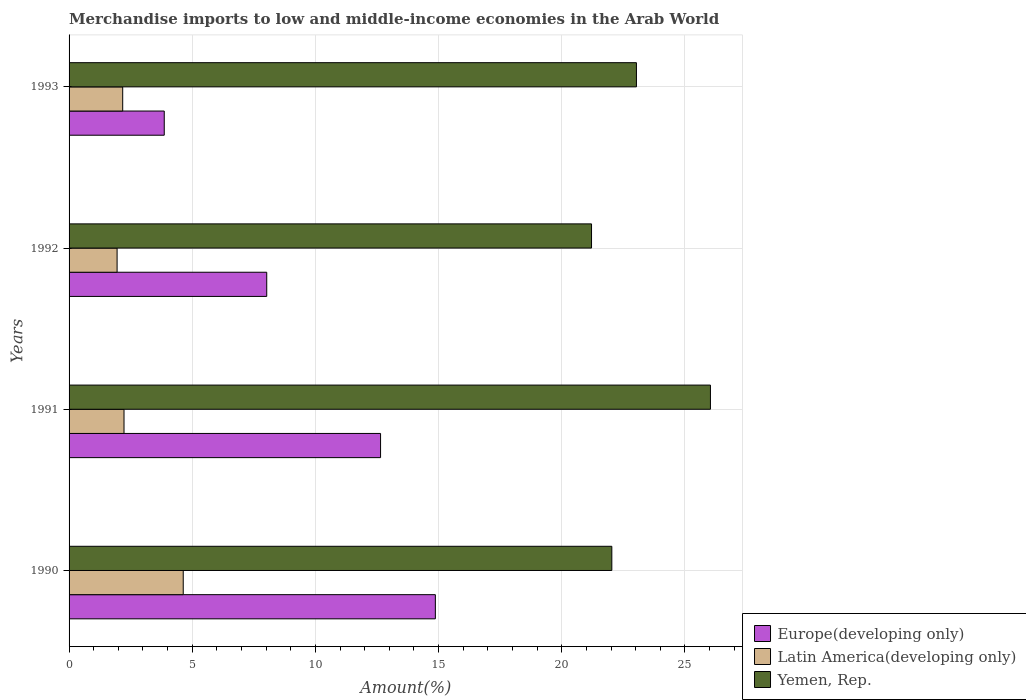How many groups of bars are there?
Offer a terse response. 4. How many bars are there on the 4th tick from the top?
Provide a short and direct response. 3. What is the percentage of amount earned from merchandise imports in Europe(developing only) in 1993?
Your answer should be compact. 3.86. Across all years, what is the maximum percentage of amount earned from merchandise imports in Yemen, Rep.?
Provide a succinct answer. 26.04. Across all years, what is the minimum percentage of amount earned from merchandise imports in Yemen, Rep.?
Keep it short and to the point. 21.21. In which year was the percentage of amount earned from merchandise imports in Yemen, Rep. maximum?
Ensure brevity in your answer.  1991. What is the total percentage of amount earned from merchandise imports in Yemen, Rep. in the graph?
Provide a short and direct response. 92.31. What is the difference between the percentage of amount earned from merchandise imports in Latin America(developing only) in 1991 and that in 1993?
Keep it short and to the point. 0.05. What is the difference between the percentage of amount earned from merchandise imports in Latin America(developing only) in 1992 and the percentage of amount earned from merchandise imports in Europe(developing only) in 1991?
Provide a succinct answer. -10.7. What is the average percentage of amount earned from merchandise imports in Europe(developing only) per year?
Make the answer very short. 9.85. In the year 1993, what is the difference between the percentage of amount earned from merchandise imports in Europe(developing only) and percentage of amount earned from merchandise imports in Latin America(developing only)?
Provide a short and direct response. 1.69. In how many years, is the percentage of amount earned from merchandise imports in Yemen, Rep. greater than 16 %?
Keep it short and to the point. 4. What is the ratio of the percentage of amount earned from merchandise imports in Europe(developing only) in 1991 to that in 1993?
Ensure brevity in your answer.  3.27. Is the percentage of amount earned from merchandise imports in Europe(developing only) in 1990 less than that in 1993?
Offer a very short reply. No. Is the difference between the percentage of amount earned from merchandise imports in Europe(developing only) in 1991 and 1992 greater than the difference between the percentage of amount earned from merchandise imports in Latin America(developing only) in 1991 and 1992?
Offer a terse response. Yes. What is the difference between the highest and the second highest percentage of amount earned from merchandise imports in Latin America(developing only)?
Provide a short and direct response. 2.4. What is the difference between the highest and the lowest percentage of amount earned from merchandise imports in Latin America(developing only)?
Ensure brevity in your answer.  2.68. In how many years, is the percentage of amount earned from merchandise imports in Europe(developing only) greater than the average percentage of amount earned from merchandise imports in Europe(developing only) taken over all years?
Your answer should be very brief. 2. Is the sum of the percentage of amount earned from merchandise imports in Latin America(developing only) in 1990 and 1991 greater than the maximum percentage of amount earned from merchandise imports in Yemen, Rep. across all years?
Give a very brief answer. No. What does the 1st bar from the top in 1992 represents?
Ensure brevity in your answer.  Yemen, Rep. What does the 1st bar from the bottom in 1991 represents?
Offer a terse response. Europe(developing only). How many bars are there?
Make the answer very short. 12. How many years are there in the graph?
Make the answer very short. 4. Are the values on the major ticks of X-axis written in scientific E-notation?
Your answer should be compact. No. Does the graph contain grids?
Offer a terse response. Yes. How many legend labels are there?
Offer a very short reply. 3. What is the title of the graph?
Your response must be concise. Merchandise imports to low and middle-income economies in the Arab World. Does "Singapore" appear as one of the legend labels in the graph?
Give a very brief answer. No. What is the label or title of the X-axis?
Give a very brief answer. Amount(%). What is the label or title of the Y-axis?
Your answer should be very brief. Years. What is the Amount(%) of Europe(developing only) in 1990?
Keep it short and to the point. 14.87. What is the Amount(%) in Latin America(developing only) in 1990?
Keep it short and to the point. 4.63. What is the Amount(%) in Yemen, Rep. in 1990?
Your answer should be compact. 22.03. What is the Amount(%) of Europe(developing only) in 1991?
Give a very brief answer. 12.64. What is the Amount(%) in Latin America(developing only) in 1991?
Provide a succinct answer. 2.23. What is the Amount(%) of Yemen, Rep. in 1991?
Ensure brevity in your answer.  26.04. What is the Amount(%) in Europe(developing only) in 1992?
Provide a short and direct response. 8.02. What is the Amount(%) in Latin America(developing only) in 1992?
Give a very brief answer. 1.95. What is the Amount(%) in Yemen, Rep. in 1992?
Offer a very short reply. 21.21. What is the Amount(%) of Europe(developing only) in 1993?
Offer a terse response. 3.86. What is the Amount(%) in Latin America(developing only) in 1993?
Give a very brief answer. 2.18. What is the Amount(%) of Yemen, Rep. in 1993?
Your response must be concise. 23.03. Across all years, what is the maximum Amount(%) of Europe(developing only)?
Offer a very short reply. 14.87. Across all years, what is the maximum Amount(%) in Latin America(developing only)?
Your answer should be very brief. 4.63. Across all years, what is the maximum Amount(%) of Yemen, Rep.?
Offer a very short reply. 26.04. Across all years, what is the minimum Amount(%) in Europe(developing only)?
Your answer should be compact. 3.86. Across all years, what is the minimum Amount(%) of Latin America(developing only)?
Your answer should be compact. 1.95. Across all years, what is the minimum Amount(%) in Yemen, Rep.?
Your answer should be very brief. 21.21. What is the total Amount(%) of Europe(developing only) in the graph?
Provide a short and direct response. 39.4. What is the total Amount(%) in Latin America(developing only) in the graph?
Give a very brief answer. 10.99. What is the total Amount(%) of Yemen, Rep. in the graph?
Offer a terse response. 92.31. What is the difference between the Amount(%) of Europe(developing only) in 1990 and that in 1991?
Your response must be concise. 2.22. What is the difference between the Amount(%) in Latin America(developing only) in 1990 and that in 1991?
Give a very brief answer. 2.4. What is the difference between the Amount(%) of Yemen, Rep. in 1990 and that in 1991?
Your answer should be compact. -4. What is the difference between the Amount(%) in Europe(developing only) in 1990 and that in 1992?
Make the answer very short. 6.85. What is the difference between the Amount(%) of Latin America(developing only) in 1990 and that in 1992?
Give a very brief answer. 2.69. What is the difference between the Amount(%) in Yemen, Rep. in 1990 and that in 1992?
Ensure brevity in your answer.  0.82. What is the difference between the Amount(%) in Europe(developing only) in 1990 and that in 1993?
Your answer should be compact. 11.01. What is the difference between the Amount(%) in Latin America(developing only) in 1990 and that in 1993?
Keep it short and to the point. 2.46. What is the difference between the Amount(%) of Yemen, Rep. in 1990 and that in 1993?
Ensure brevity in your answer.  -1. What is the difference between the Amount(%) of Europe(developing only) in 1991 and that in 1992?
Keep it short and to the point. 4.62. What is the difference between the Amount(%) in Latin America(developing only) in 1991 and that in 1992?
Provide a succinct answer. 0.28. What is the difference between the Amount(%) of Yemen, Rep. in 1991 and that in 1992?
Provide a short and direct response. 4.83. What is the difference between the Amount(%) in Europe(developing only) in 1991 and that in 1993?
Give a very brief answer. 8.78. What is the difference between the Amount(%) of Latin America(developing only) in 1991 and that in 1993?
Keep it short and to the point. 0.05. What is the difference between the Amount(%) of Yemen, Rep. in 1991 and that in 1993?
Provide a succinct answer. 3. What is the difference between the Amount(%) in Europe(developing only) in 1992 and that in 1993?
Offer a very short reply. 4.16. What is the difference between the Amount(%) in Latin America(developing only) in 1992 and that in 1993?
Your answer should be very brief. -0.23. What is the difference between the Amount(%) of Yemen, Rep. in 1992 and that in 1993?
Make the answer very short. -1.82. What is the difference between the Amount(%) in Europe(developing only) in 1990 and the Amount(%) in Latin America(developing only) in 1991?
Provide a succinct answer. 12.64. What is the difference between the Amount(%) of Europe(developing only) in 1990 and the Amount(%) of Yemen, Rep. in 1991?
Give a very brief answer. -11.17. What is the difference between the Amount(%) in Latin America(developing only) in 1990 and the Amount(%) in Yemen, Rep. in 1991?
Ensure brevity in your answer.  -21.4. What is the difference between the Amount(%) in Europe(developing only) in 1990 and the Amount(%) in Latin America(developing only) in 1992?
Give a very brief answer. 12.92. What is the difference between the Amount(%) of Europe(developing only) in 1990 and the Amount(%) of Yemen, Rep. in 1992?
Provide a short and direct response. -6.34. What is the difference between the Amount(%) in Latin America(developing only) in 1990 and the Amount(%) in Yemen, Rep. in 1992?
Offer a terse response. -16.57. What is the difference between the Amount(%) in Europe(developing only) in 1990 and the Amount(%) in Latin America(developing only) in 1993?
Provide a short and direct response. 12.69. What is the difference between the Amount(%) of Europe(developing only) in 1990 and the Amount(%) of Yemen, Rep. in 1993?
Ensure brevity in your answer.  -8.16. What is the difference between the Amount(%) in Latin America(developing only) in 1990 and the Amount(%) in Yemen, Rep. in 1993?
Your response must be concise. -18.4. What is the difference between the Amount(%) of Europe(developing only) in 1991 and the Amount(%) of Latin America(developing only) in 1992?
Offer a very short reply. 10.7. What is the difference between the Amount(%) of Europe(developing only) in 1991 and the Amount(%) of Yemen, Rep. in 1992?
Give a very brief answer. -8.56. What is the difference between the Amount(%) in Latin America(developing only) in 1991 and the Amount(%) in Yemen, Rep. in 1992?
Provide a succinct answer. -18.98. What is the difference between the Amount(%) of Europe(developing only) in 1991 and the Amount(%) of Latin America(developing only) in 1993?
Ensure brevity in your answer.  10.47. What is the difference between the Amount(%) in Europe(developing only) in 1991 and the Amount(%) in Yemen, Rep. in 1993?
Offer a terse response. -10.39. What is the difference between the Amount(%) of Latin America(developing only) in 1991 and the Amount(%) of Yemen, Rep. in 1993?
Your answer should be very brief. -20.8. What is the difference between the Amount(%) in Europe(developing only) in 1992 and the Amount(%) in Latin America(developing only) in 1993?
Keep it short and to the point. 5.85. What is the difference between the Amount(%) in Europe(developing only) in 1992 and the Amount(%) in Yemen, Rep. in 1993?
Offer a terse response. -15.01. What is the difference between the Amount(%) of Latin America(developing only) in 1992 and the Amount(%) of Yemen, Rep. in 1993?
Keep it short and to the point. -21.08. What is the average Amount(%) of Europe(developing only) per year?
Provide a short and direct response. 9.85. What is the average Amount(%) in Latin America(developing only) per year?
Make the answer very short. 2.75. What is the average Amount(%) in Yemen, Rep. per year?
Offer a very short reply. 23.08. In the year 1990, what is the difference between the Amount(%) in Europe(developing only) and Amount(%) in Latin America(developing only)?
Provide a succinct answer. 10.24. In the year 1990, what is the difference between the Amount(%) in Europe(developing only) and Amount(%) in Yemen, Rep.?
Ensure brevity in your answer.  -7.16. In the year 1990, what is the difference between the Amount(%) in Latin America(developing only) and Amount(%) in Yemen, Rep.?
Offer a very short reply. -17.4. In the year 1991, what is the difference between the Amount(%) in Europe(developing only) and Amount(%) in Latin America(developing only)?
Make the answer very short. 10.41. In the year 1991, what is the difference between the Amount(%) in Europe(developing only) and Amount(%) in Yemen, Rep.?
Your answer should be compact. -13.39. In the year 1991, what is the difference between the Amount(%) of Latin America(developing only) and Amount(%) of Yemen, Rep.?
Your answer should be very brief. -23.81. In the year 1992, what is the difference between the Amount(%) of Europe(developing only) and Amount(%) of Latin America(developing only)?
Provide a succinct answer. 6.08. In the year 1992, what is the difference between the Amount(%) in Europe(developing only) and Amount(%) in Yemen, Rep.?
Offer a terse response. -13.19. In the year 1992, what is the difference between the Amount(%) of Latin America(developing only) and Amount(%) of Yemen, Rep.?
Give a very brief answer. -19.26. In the year 1993, what is the difference between the Amount(%) of Europe(developing only) and Amount(%) of Latin America(developing only)?
Provide a short and direct response. 1.69. In the year 1993, what is the difference between the Amount(%) of Europe(developing only) and Amount(%) of Yemen, Rep.?
Your response must be concise. -19.17. In the year 1993, what is the difference between the Amount(%) of Latin America(developing only) and Amount(%) of Yemen, Rep.?
Your response must be concise. -20.86. What is the ratio of the Amount(%) of Europe(developing only) in 1990 to that in 1991?
Provide a succinct answer. 1.18. What is the ratio of the Amount(%) of Latin America(developing only) in 1990 to that in 1991?
Ensure brevity in your answer.  2.08. What is the ratio of the Amount(%) of Yemen, Rep. in 1990 to that in 1991?
Make the answer very short. 0.85. What is the ratio of the Amount(%) in Europe(developing only) in 1990 to that in 1992?
Your answer should be very brief. 1.85. What is the ratio of the Amount(%) of Latin America(developing only) in 1990 to that in 1992?
Give a very brief answer. 2.38. What is the ratio of the Amount(%) of Yemen, Rep. in 1990 to that in 1992?
Offer a very short reply. 1.04. What is the ratio of the Amount(%) of Europe(developing only) in 1990 to that in 1993?
Give a very brief answer. 3.85. What is the ratio of the Amount(%) in Latin America(developing only) in 1990 to that in 1993?
Make the answer very short. 2.13. What is the ratio of the Amount(%) of Yemen, Rep. in 1990 to that in 1993?
Provide a short and direct response. 0.96. What is the ratio of the Amount(%) of Europe(developing only) in 1991 to that in 1992?
Provide a short and direct response. 1.58. What is the ratio of the Amount(%) of Latin America(developing only) in 1991 to that in 1992?
Your response must be concise. 1.14. What is the ratio of the Amount(%) in Yemen, Rep. in 1991 to that in 1992?
Your answer should be compact. 1.23. What is the ratio of the Amount(%) in Europe(developing only) in 1991 to that in 1993?
Make the answer very short. 3.27. What is the ratio of the Amount(%) of Latin America(developing only) in 1991 to that in 1993?
Your response must be concise. 1.02. What is the ratio of the Amount(%) of Yemen, Rep. in 1991 to that in 1993?
Keep it short and to the point. 1.13. What is the ratio of the Amount(%) of Europe(developing only) in 1992 to that in 1993?
Provide a succinct answer. 2.08. What is the ratio of the Amount(%) in Latin America(developing only) in 1992 to that in 1993?
Ensure brevity in your answer.  0.9. What is the ratio of the Amount(%) of Yemen, Rep. in 1992 to that in 1993?
Offer a terse response. 0.92. What is the difference between the highest and the second highest Amount(%) of Europe(developing only)?
Your answer should be compact. 2.22. What is the difference between the highest and the second highest Amount(%) of Latin America(developing only)?
Keep it short and to the point. 2.4. What is the difference between the highest and the second highest Amount(%) in Yemen, Rep.?
Your answer should be compact. 3. What is the difference between the highest and the lowest Amount(%) of Europe(developing only)?
Make the answer very short. 11.01. What is the difference between the highest and the lowest Amount(%) in Latin America(developing only)?
Your answer should be compact. 2.69. What is the difference between the highest and the lowest Amount(%) in Yemen, Rep.?
Offer a terse response. 4.83. 